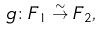<formula> <loc_0><loc_0><loc_500><loc_500>g \colon F _ { 1 } \stackrel { \sim } { \to } F _ { 2 } ,</formula> 